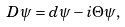<formula> <loc_0><loc_0><loc_500><loc_500>D \psi = d \psi - i \Theta \psi ,</formula> 